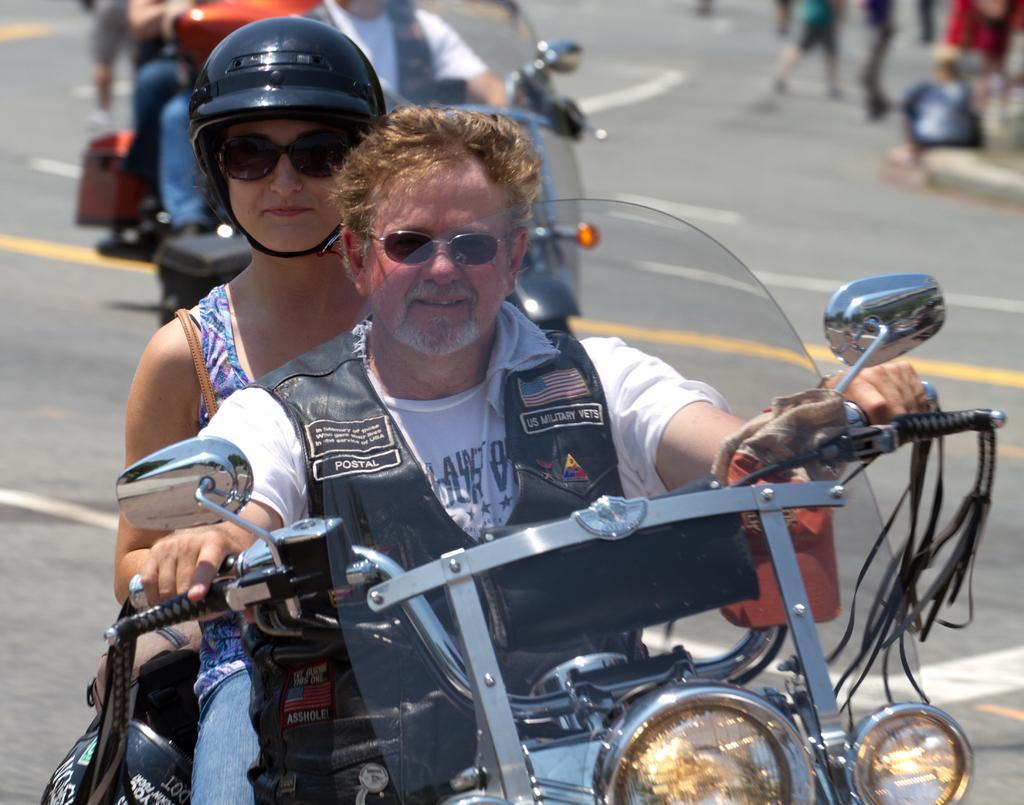Please provide a concise description of this image. In this image there are two person riding a bike. The woman is wearing a helmet. 